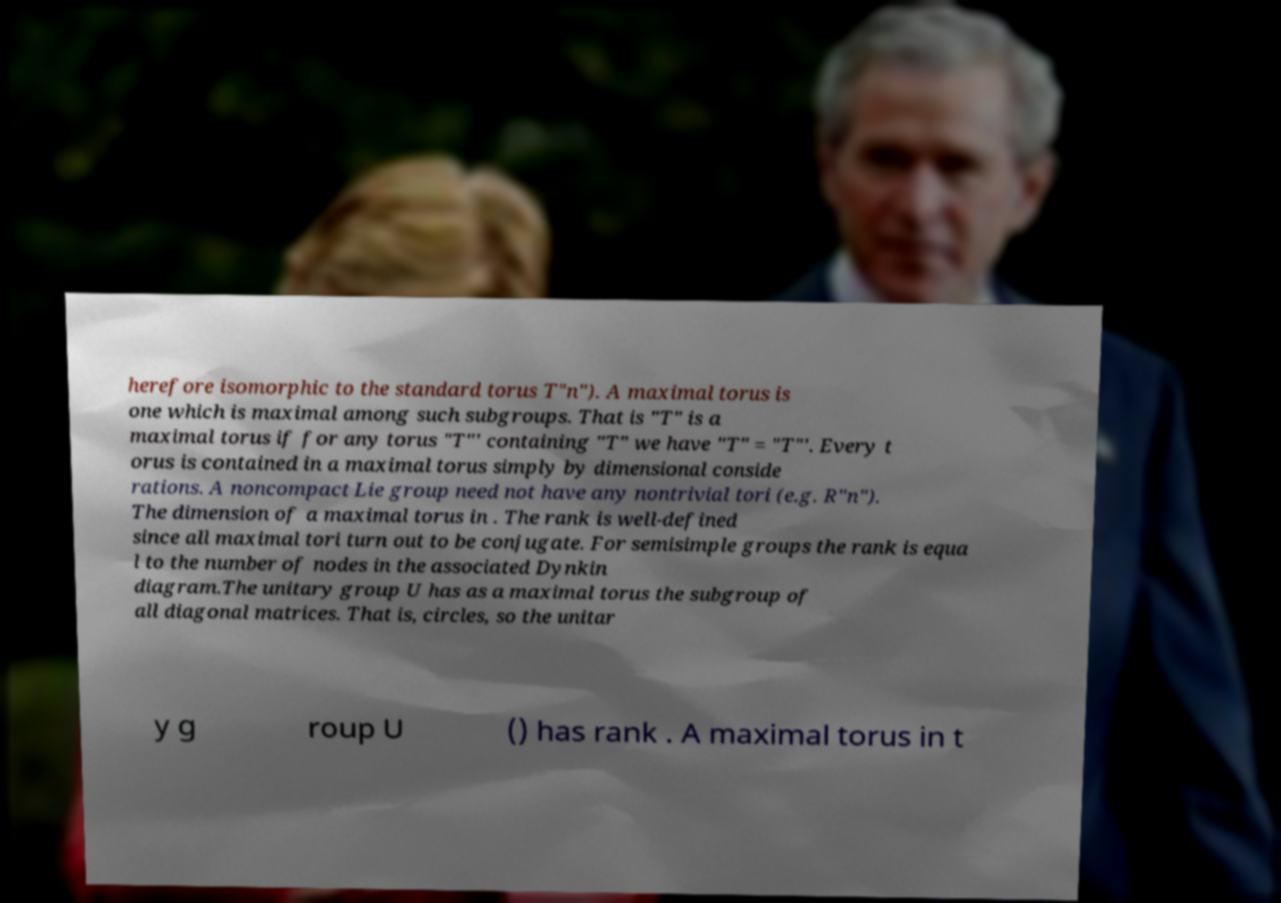Please identify and transcribe the text found in this image. herefore isomorphic to the standard torus T"n"). A maximal torus is one which is maximal among such subgroups. That is "T" is a maximal torus if for any torus "T"′ containing "T" we have "T" = "T"′. Every t orus is contained in a maximal torus simply by dimensional conside rations. A noncompact Lie group need not have any nontrivial tori (e.g. R"n"). The dimension of a maximal torus in . The rank is well-defined since all maximal tori turn out to be conjugate. For semisimple groups the rank is equa l to the number of nodes in the associated Dynkin diagram.The unitary group U has as a maximal torus the subgroup of all diagonal matrices. That is, circles, so the unitar y g roup U () has rank . A maximal torus in t 